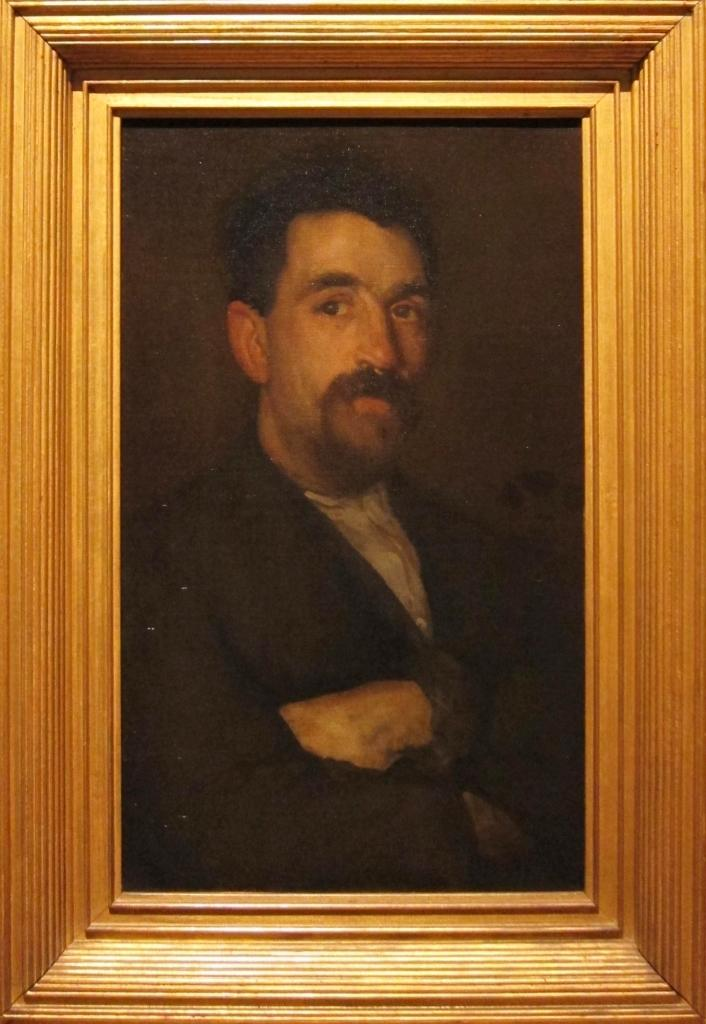What object is visible in the image that typically holds a picture? There is a photo frame present in the image. What can be seen inside the photo frame? There is a picture of a man in the photo frame. How many giraffes are visible in the image? There are no giraffes present in the image. What symbol of peace can be seen in the image? There is no symbol of peace present in the image. 